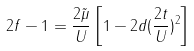Convert formula to latex. <formula><loc_0><loc_0><loc_500><loc_500>2 f - 1 = \frac { 2 \tilde { \mu } } { U } \left [ 1 - 2 d ( \frac { 2 t } { U } ) ^ { 2 } \right ]</formula> 